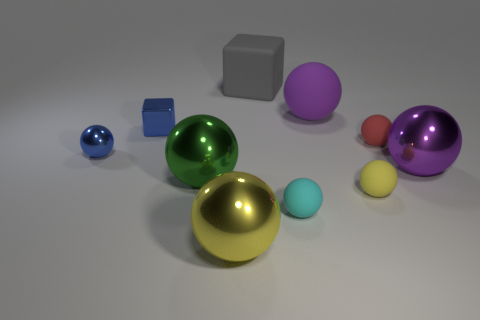There is a block that is the same color as the tiny shiny sphere; what material is it?
Your response must be concise. Metal. What number of other things are the same color as the metallic cube?
Provide a succinct answer. 1. The rubber cube has what color?
Keep it short and to the point. Gray. There is a small rubber sphere that is behind the shiny ball behind the shiny ball on the right side of the purple rubber sphere; what is its color?
Ensure brevity in your answer.  Red. Do the big green thing and the matte thing in front of the yellow matte sphere have the same shape?
Keep it short and to the point. Yes. What is the color of the metallic ball that is both behind the big green object and to the left of the large yellow shiny thing?
Your answer should be very brief. Blue. Is there another large object that has the same shape as the large gray rubber thing?
Give a very brief answer. No. Is the color of the big matte cube the same as the small metal ball?
Keep it short and to the point. No. Is there a yellow thing to the left of the blue metallic thing that is right of the tiny blue ball?
Your answer should be very brief. No. What number of objects are either tiny balls that are to the left of the large rubber block or large metal balls behind the big yellow thing?
Give a very brief answer. 3. 